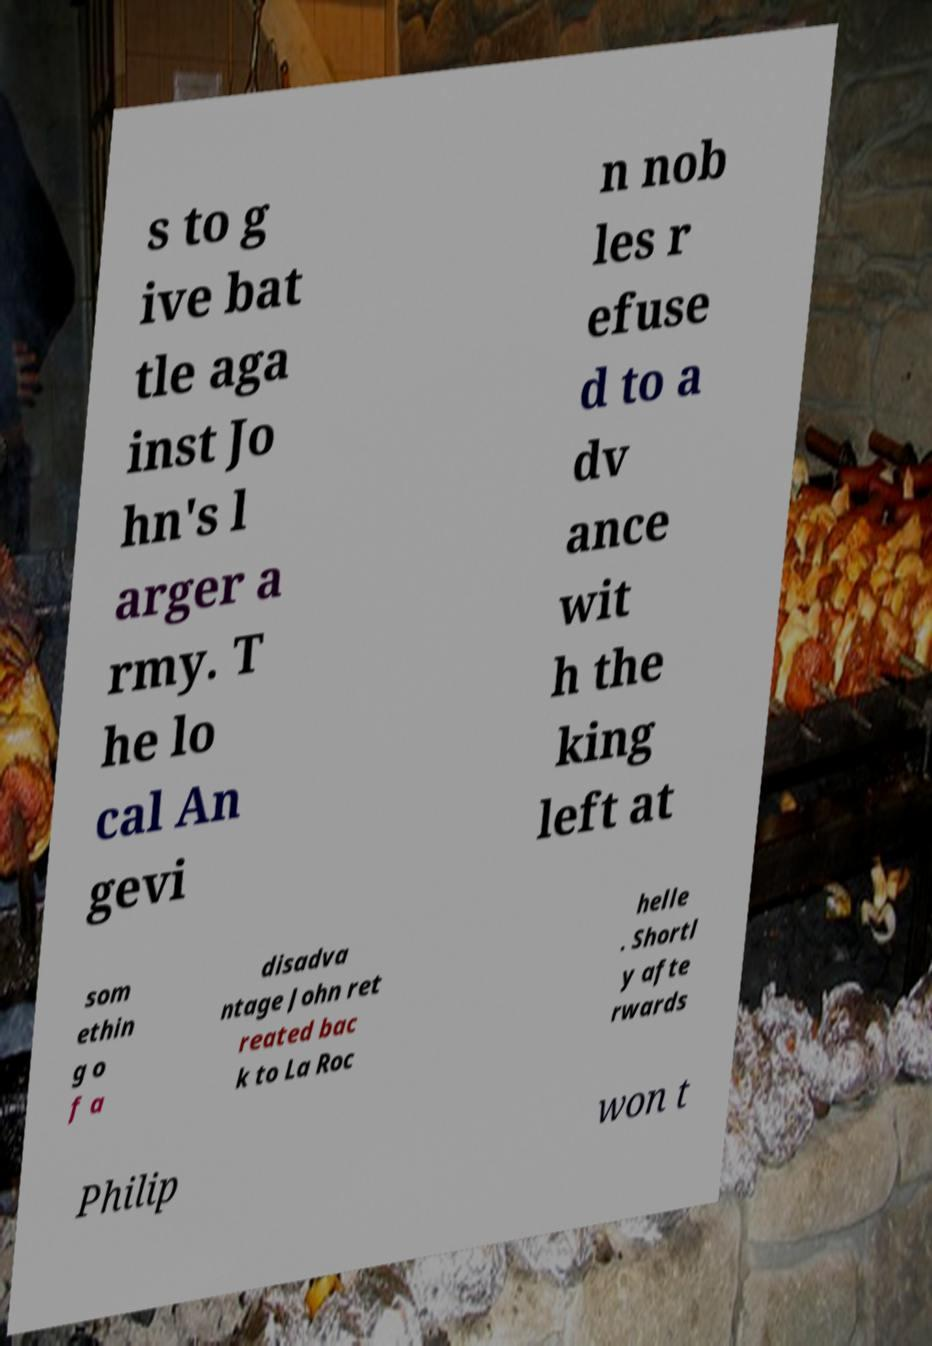There's text embedded in this image that I need extracted. Can you transcribe it verbatim? s to g ive bat tle aga inst Jo hn's l arger a rmy. T he lo cal An gevi n nob les r efuse d to a dv ance wit h the king left at som ethin g o f a disadva ntage John ret reated bac k to La Roc helle . Shortl y afte rwards Philip won t 